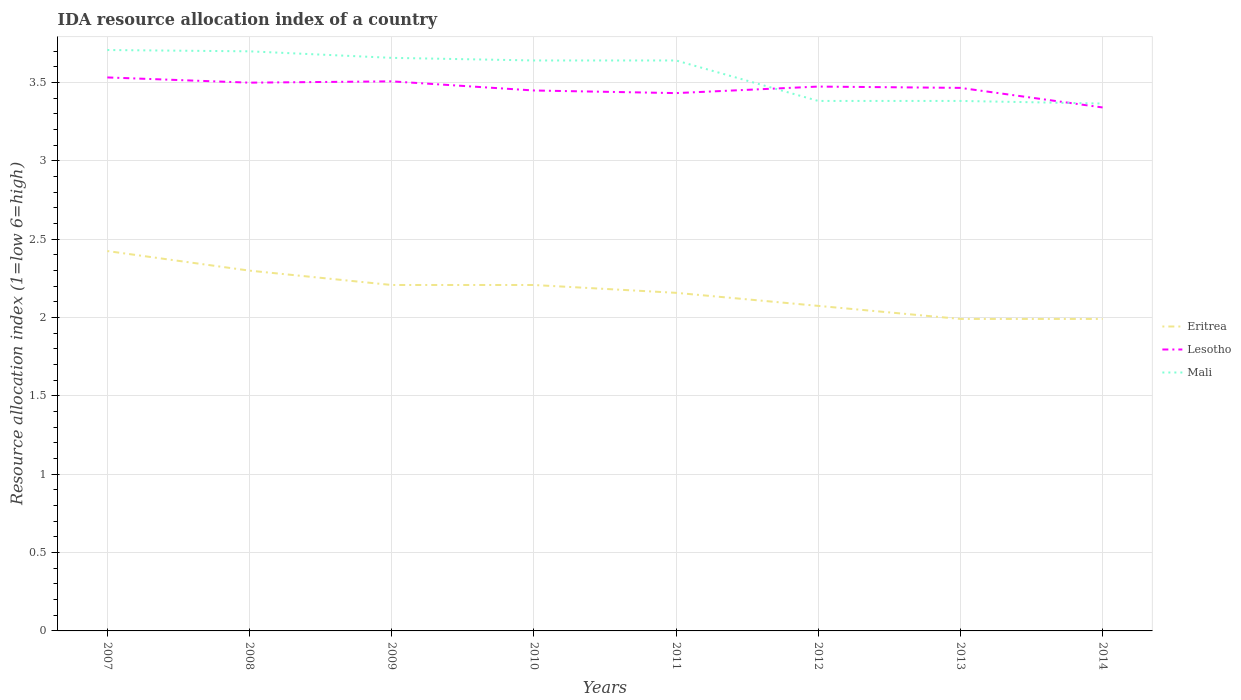How many different coloured lines are there?
Keep it short and to the point. 3. Across all years, what is the maximum IDA resource allocation index in Eritrea?
Your answer should be compact. 1.99. In which year was the IDA resource allocation index in Lesotho maximum?
Give a very brief answer. 2014. What is the total IDA resource allocation index in Lesotho in the graph?
Make the answer very short. 0.03. What is the difference between the highest and the second highest IDA resource allocation index in Mali?
Ensure brevity in your answer.  0.34. How many lines are there?
Provide a short and direct response. 3. Does the graph contain any zero values?
Provide a succinct answer. No. Does the graph contain grids?
Keep it short and to the point. Yes. Where does the legend appear in the graph?
Your answer should be very brief. Center right. What is the title of the graph?
Provide a succinct answer. IDA resource allocation index of a country. What is the label or title of the Y-axis?
Provide a short and direct response. Resource allocation index (1=low 6=high). What is the Resource allocation index (1=low 6=high) in Eritrea in 2007?
Provide a short and direct response. 2.42. What is the Resource allocation index (1=low 6=high) of Lesotho in 2007?
Ensure brevity in your answer.  3.53. What is the Resource allocation index (1=low 6=high) in Mali in 2007?
Offer a very short reply. 3.71. What is the Resource allocation index (1=low 6=high) in Eritrea in 2008?
Offer a very short reply. 2.3. What is the Resource allocation index (1=low 6=high) of Eritrea in 2009?
Your response must be concise. 2.21. What is the Resource allocation index (1=low 6=high) in Lesotho in 2009?
Your answer should be very brief. 3.51. What is the Resource allocation index (1=low 6=high) of Mali in 2009?
Give a very brief answer. 3.66. What is the Resource allocation index (1=low 6=high) of Eritrea in 2010?
Offer a very short reply. 2.21. What is the Resource allocation index (1=low 6=high) of Lesotho in 2010?
Provide a succinct answer. 3.45. What is the Resource allocation index (1=low 6=high) in Mali in 2010?
Your response must be concise. 3.64. What is the Resource allocation index (1=low 6=high) in Eritrea in 2011?
Your response must be concise. 2.16. What is the Resource allocation index (1=low 6=high) of Lesotho in 2011?
Provide a short and direct response. 3.43. What is the Resource allocation index (1=low 6=high) of Mali in 2011?
Give a very brief answer. 3.64. What is the Resource allocation index (1=low 6=high) of Eritrea in 2012?
Your answer should be very brief. 2.08. What is the Resource allocation index (1=low 6=high) of Lesotho in 2012?
Provide a short and direct response. 3.48. What is the Resource allocation index (1=low 6=high) of Mali in 2012?
Offer a very short reply. 3.38. What is the Resource allocation index (1=low 6=high) in Eritrea in 2013?
Keep it short and to the point. 1.99. What is the Resource allocation index (1=low 6=high) of Lesotho in 2013?
Keep it short and to the point. 3.47. What is the Resource allocation index (1=low 6=high) in Mali in 2013?
Offer a terse response. 3.38. What is the Resource allocation index (1=low 6=high) of Eritrea in 2014?
Give a very brief answer. 1.99. What is the Resource allocation index (1=low 6=high) in Lesotho in 2014?
Provide a succinct answer. 3.34. What is the Resource allocation index (1=low 6=high) in Mali in 2014?
Offer a very short reply. 3.37. Across all years, what is the maximum Resource allocation index (1=low 6=high) in Eritrea?
Give a very brief answer. 2.42. Across all years, what is the maximum Resource allocation index (1=low 6=high) in Lesotho?
Ensure brevity in your answer.  3.53. Across all years, what is the maximum Resource allocation index (1=low 6=high) of Mali?
Your response must be concise. 3.71. Across all years, what is the minimum Resource allocation index (1=low 6=high) of Eritrea?
Your response must be concise. 1.99. Across all years, what is the minimum Resource allocation index (1=low 6=high) in Lesotho?
Ensure brevity in your answer.  3.34. Across all years, what is the minimum Resource allocation index (1=low 6=high) of Mali?
Offer a very short reply. 3.37. What is the total Resource allocation index (1=low 6=high) of Eritrea in the graph?
Your answer should be compact. 17.36. What is the total Resource allocation index (1=low 6=high) of Lesotho in the graph?
Provide a succinct answer. 27.71. What is the total Resource allocation index (1=low 6=high) in Mali in the graph?
Make the answer very short. 28.48. What is the difference between the Resource allocation index (1=low 6=high) in Mali in 2007 and that in 2008?
Keep it short and to the point. 0.01. What is the difference between the Resource allocation index (1=low 6=high) in Eritrea in 2007 and that in 2009?
Offer a very short reply. 0.22. What is the difference between the Resource allocation index (1=low 6=high) of Lesotho in 2007 and that in 2009?
Your answer should be compact. 0.03. What is the difference between the Resource allocation index (1=low 6=high) in Eritrea in 2007 and that in 2010?
Make the answer very short. 0.22. What is the difference between the Resource allocation index (1=low 6=high) in Lesotho in 2007 and that in 2010?
Offer a very short reply. 0.08. What is the difference between the Resource allocation index (1=low 6=high) in Mali in 2007 and that in 2010?
Provide a succinct answer. 0.07. What is the difference between the Resource allocation index (1=low 6=high) in Eritrea in 2007 and that in 2011?
Give a very brief answer. 0.27. What is the difference between the Resource allocation index (1=low 6=high) of Lesotho in 2007 and that in 2011?
Offer a very short reply. 0.1. What is the difference between the Resource allocation index (1=low 6=high) of Mali in 2007 and that in 2011?
Give a very brief answer. 0.07. What is the difference between the Resource allocation index (1=low 6=high) in Lesotho in 2007 and that in 2012?
Your response must be concise. 0.06. What is the difference between the Resource allocation index (1=low 6=high) of Mali in 2007 and that in 2012?
Give a very brief answer. 0.33. What is the difference between the Resource allocation index (1=low 6=high) in Eritrea in 2007 and that in 2013?
Offer a very short reply. 0.43. What is the difference between the Resource allocation index (1=low 6=high) in Lesotho in 2007 and that in 2013?
Offer a terse response. 0.07. What is the difference between the Resource allocation index (1=low 6=high) in Mali in 2007 and that in 2013?
Provide a short and direct response. 0.33. What is the difference between the Resource allocation index (1=low 6=high) in Eritrea in 2007 and that in 2014?
Keep it short and to the point. 0.43. What is the difference between the Resource allocation index (1=low 6=high) in Lesotho in 2007 and that in 2014?
Provide a short and direct response. 0.19. What is the difference between the Resource allocation index (1=low 6=high) of Mali in 2007 and that in 2014?
Provide a short and direct response. 0.34. What is the difference between the Resource allocation index (1=low 6=high) in Eritrea in 2008 and that in 2009?
Your response must be concise. 0.09. What is the difference between the Resource allocation index (1=low 6=high) of Lesotho in 2008 and that in 2009?
Give a very brief answer. -0.01. What is the difference between the Resource allocation index (1=low 6=high) of Mali in 2008 and that in 2009?
Make the answer very short. 0.04. What is the difference between the Resource allocation index (1=low 6=high) of Eritrea in 2008 and that in 2010?
Your answer should be very brief. 0.09. What is the difference between the Resource allocation index (1=low 6=high) of Lesotho in 2008 and that in 2010?
Provide a succinct answer. 0.05. What is the difference between the Resource allocation index (1=low 6=high) in Mali in 2008 and that in 2010?
Ensure brevity in your answer.  0.06. What is the difference between the Resource allocation index (1=low 6=high) in Eritrea in 2008 and that in 2011?
Keep it short and to the point. 0.14. What is the difference between the Resource allocation index (1=low 6=high) in Lesotho in 2008 and that in 2011?
Provide a short and direct response. 0.07. What is the difference between the Resource allocation index (1=low 6=high) of Mali in 2008 and that in 2011?
Keep it short and to the point. 0.06. What is the difference between the Resource allocation index (1=low 6=high) in Eritrea in 2008 and that in 2012?
Offer a terse response. 0.23. What is the difference between the Resource allocation index (1=low 6=high) in Lesotho in 2008 and that in 2012?
Give a very brief answer. 0.03. What is the difference between the Resource allocation index (1=low 6=high) in Mali in 2008 and that in 2012?
Offer a terse response. 0.32. What is the difference between the Resource allocation index (1=low 6=high) in Eritrea in 2008 and that in 2013?
Provide a succinct answer. 0.31. What is the difference between the Resource allocation index (1=low 6=high) of Mali in 2008 and that in 2013?
Offer a very short reply. 0.32. What is the difference between the Resource allocation index (1=low 6=high) of Eritrea in 2008 and that in 2014?
Offer a very short reply. 0.31. What is the difference between the Resource allocation index (1=low 6=high) of Lesotho in 2008 and that in 2014?
Your answer should be very brief. 0.16. What is the difference between the Resource allocation index (1=low 6=high) of Mali in 2008 and that in 2014?
Make the answer very short. 0.33. What is the difference between the Resource allocation index (1=low 6=high) in Lesotho in 2009 and that in 2010?
Make the answer very short. 0.06. What is the difference between the Resource allocation index (1=low 6=high) in Mali in 2009 and that in 2010?
Make the answer very short. 0.02. What is the difference between the Resource allocation index (1=low 6=high) in Eritrea in 2009 and that in 2011?
Give a very brief answer. 0.05. What is the difference between the Resource allocation index (1=low 6=high) of Lesotho in 2009 and that in 2011?
Offer a terse response. 0.07. What is the difference between the Resource allocation index (1=low 6=high) of Mali in 2009 and that in 2011?
Ensure brevity in your answer.  0.02. What is the difference between the Resource allocation index (1=low 6=high) in Eritrea in 2009 and that in 2012?
Give a very brief answer. 0.13. What is the difference between the Resource allocation index (1=low 6=high) in Lesotho in 2009 and that in 2012?
Provide a succinct answer. 0.03. What is the difference between the Resource allocation index (1=low 6=high) of Mali in 2009 and that in 2012?
Provide a short and direct response. 0.28. What is the difference between the Resource allocation index (1=low 6=high) of Eritrea in 2009 and that in 2013?
Your answer should be compact. 0.22. What is the difference between the Resource allocation index (1=low 6=high) of Lesotho in 2009 and that in 2013?
Offer a terse response. 0.04. What is the difference between the Resource allocation index (1=low 6=high) in Mali in 2009 and that in 2013?
Your response must be concise. 0.28. What is the difference between the Resource allocation index (1=low 6=high) of Eritrea in 2009 and that in 2014?
Your answer should be very brief. 0.22. What is the difference between the Resource allocation index (1=low 6=high) in Lesotho in 2009 and that in 2014?
Your answer should be compact. 0.17. What is the difference between the Resource allocation index (1=low 6=high) in Mali in 2009 and that in 2014?
Make the answer very short. 0.29. What is the difference between the Resource allocation index (1=low 6=high) in Lesotho in 2010 and that in 2011?
Your answer should be very brief. 0.02. What is the difference between the Resource allocation index (1=low 6=high) in Eritrea in 2010 and that in 2012?
Keep it short and to the point. 0.13. What is the difference between the Resource allocation index (1=low 6=high) of Lesotho in 2010 and that in 2012?
Offer a very short reply. -0.03. What is the difference between the Resource allocation index (1=low 6=high) of Mali in 2010 and that in 2012?
Your response must be concise. 0.26. What is the difference between the Resource allocation index (1=low 6=high) of Eritrea in 2010 and that in 2013?
Provide a succinct answer. 0.22. What is the difference between the Resource allocation index (1=low 6=high) in Lesotho in 2010 and that in 2013?
Offer a terse response. -0.02. What is the difference between the Resource allocation index (1=low 6=high) of Mali in 2010 and that in 2013?
Provide a short and direct response. 0.26. What is the difference between the Resource allocation index (1=low 6=high) in Eritrea in 2010 and that in 2014?
Your answer should be compact. 0.22. What is the difference between the Resource allocation index (1=low 6=high) in Lesotho in 2010 and that in 2014?
Ensure brevity in your answer.  0.11. What is the difference between the Resource allocation index (1=low 6=high) in Mali in 2010 and that in 2014?
Offer a very short reply. 0.28. What is the difference between the Resource allocation index (1=low 6=high) in Eritrea in 2011 and that in 2012?
Offer a very short reply. 0.08. What is the difference between the Resource allocation index (1=low 6=high) in Lesotho in 2011 and that in 2012?
Offer a terse response. -0.04. What is the difference between the Resource allocation index (1=low 6=high) in Mali in 2011 and that in 2012?
Offer a terse response. 0.26. What is the difference between the Resource allocation index (1=low 6=high) of Lesotho in 2011 and that in 2013?
Provide a succinct answer. -0.03. What is the difference between the Resource allocation index (1=low 6=high) of Mali in 2011 and that in 2013?
Your answer should be compact. 0.26. What is the difference between the Resource allocation index (1=low 6=high) in Eritrea in 2011 and that in 2014?
Offer a terse response. 0.17. What is the difference between the Resource allocation index (1=low 6=high) of Lesotho in 2011 and that in 2014?
Provide a short and direct response. 0.09. What is the difference between the Resource allocation index (1=low 6=high) of Mali in 2011 and that in 2014?
Your response must be concise. 0.28. What is the difference between the Resource allocation index (1=low 6=high) of Eritrea in 2012 and that in 2013?
Your answer should be very brief. 0.08. What is the difference between the Resource allocation index (1=low 6=high) of Lesotho in 2012 and that in 2013?
Provide a succinct answer. 0.01. What is the difference between the Resource allocation index (1=low 6=high) of Eritrea in 2012 and that in 2014?
Make the answer very short. 0.08. What is the difference between the Resource allocation index (1=low 6=high) in Lesotho in 2012 and that in 2014?
Your answer should be compact. 0.13. What is the difference between the Resource allocation index (1=low 6=high) in Mali in 2012 and that in 2014?
Provide a succinct answer. 0.02. What is the difference between the Resource allocation index (1=low 6=high) of Lesotho in 2013 and that in 2014?
Provide a short and direct response. 0.12. What is the difference between the Resource allocation index (1=low 6=high) of Mali in 2013 and that in 2014?
Keep it short and to the point. 0.02. What is the difference between the Resource allocation index (1=low 6=high) in Eritrea in 2007 and the Resource allocation index (1=low 6=high) in Lesotho in 2008?
Keep it short and to the point. -1.07. What is the difference between the Resource allocation index (1=low 6=high) in Eritrea in 2007 and the Resource allocation index (1=low 6=high) in Mali in 2008?
Provide a succinct answer. -1.27. What is the difference between the Resource allocation index (1=low 6=high) in Lesotho in 2007 and the Resource allocation index (1=low 6=high) in Mali in 2008?
Provide a short and direct response. -0.17. What is the difference between the Resource allocation index (1=low 6=high) in Eritrea in 2007 and the Resource allocation index (1=low 6=high) in Lesotho in 2009?
Provide a short and direct response. -1.08. What is the difference between the Resource allocation index (1=low 6=high) in Eritrea in 2007 and the Resource allocation index (1=low 6=high) in Mali in 2009?
Give a very brief answer. -1.23. What is the difference between the Resource allocation index (1=low 6=high) in Lesotho in 2007 and the Resource allocation index (1=low 6=high) in Mali in 2009?
Ensure brevity in your answer.  -0.12. What is the difference between the Resource allocation index (1=low 6=high) in Eritrea in 2007 and the Resource allocation index (1=low 6=high) in Lesotho in 2010?
Offer a terse response. -1.02. What is the difference between the Resource allocation index (1=low 6=high) in Eritrea in 2007 and the Resource allocation index (1=low 6=high) in Mali in 2010?
Your answer should be very brief. -1.22. What is the difference between the Resource allocation index (1=low 6=high) of Lesotho in 2007 and the Resource allocation index (1=low 6=high) of Mali in 2010?
Provide a succinct answer. -0.11. What is the difference between the Resource allocation index (1=low 6=high) of Eritrea in 2007 and the Resource allocation index (1=low 6=high) of Lesotho in 2011?
Your answer should be compact. -1.01. What is the difference between the Resource allocation index (1=low 6=high) in Eritrea in 2007 and the Resource allocation index (1=low 6=high) in Mali in 2011?
Provide a succinct answer. -1.22. What is the difference between the Resource allocation index (1=low 6=high) of Lesotho in 2007 and the Resource allocation index (1=low 6=high) of Mali in 2011?
Your answer should be very brief. -0.11. What is the difference between the Resource allocation index (1=low 6=high) in Eritrea in 2007 and the Resource allocation index (1=low 6=high) in Lesotho in 2012?
Your answer should be compact. -1.05. What is the difference between the Resource allocation index (1=low 6=high) of Eritrea in 2007 and the Resource allocation index (1=low 6=high) of Mali in 2012?
Give a very brief answer. -0.96. What is the difference between the Resource allocation index (1=low 6=high) of Eritrea in 2007 and the Resource allocation index (1=low 6=high) of Lesotho in 2013?
Offer a terse response. -1.04. What is the difference between the Resource allocation index (1=low 6=high) of Eritrea in 2007 and the Resource allocation index (1=low 6=high) of Mali in 2013?
Make the answer very short. -0.96. What is the difference between the Resource allocation index (1=low 6=high) of Lesotho in 2007 and the Resource allocation index (1=low 6=high) of Mali in 2013?
Make the answer very short. 0.15. What is the difference between the Resource allocation index (1=low 6=high) of Eritrea in 2007 and the Resource allocation index (1=low 6=high) of Lesotho in 2014?
Provide a short and direct response. -0.92. What is the difference between the Resource allocation index (1=low 6=high) in Eritrea in 2007 and the Resource allocation index (1=low 6=high) in Mali in 2014?
Offer a terse response. -0.94. What is the difference between the Resource allocation index (1=low 6=high) in Eritrea in 2008 and the Resource allocation index (1=low 6=high) in Lesotho in 2009?
Keep it short and to the point. -1.21. What is the difference between the Resource allocation index (1=low 6=high) of Eritrea in 2008 and the Resource allocation index (1=low 6=high) of Mali in 2009?
Offer a very short reply. -1.36. What is the difference between the Resource allocation index (1=low 6=high) in Lesotho in 2008 and the Resource allocation index (1=low 6=high) in Mali in 2009?
Provide a short and direct response. -0.16. What is the difference between the Resource allocation index (1=low 6=high) of Eritrea in 2008 and the Resource allocation index (1=low 6=high) of Lesotho in 2010?
Keep it short and to the point. -1.15. What is the difference between the Resource allocation index (1=low 6=high) in Eritrea in 2008 and the Resource allocation index (1=low 6=high) in Mali in 2010?
Your answer should be compact. -1.34. What is the difference between the Resource allocation index (1=low 6=high) of Lesotho in 2008 and the Resource allocation index (1=low 6=high) of Mali in 2010?
Keep it short and to the point. -0.14. What is the difference between the Resource allocation index (1=low 6=high) in Eritrea in 2008 and the Resource allocation index (1=low 6=high) in Lesotho in 2011?
Keep it short and to the point. -1.13. What is the difference between the Resource allocation index (1=low 6=high) in Eritrea in 2008 and the Resource allocation index (1=low 6=high) in Mali in 2011?
Keep it short and to the point. -1.34. What is the difference between the Resource allocation index (1=low 6=high) in Lesotho in 2008 and the Resource allocation index (1=low 6=high) in Mali in 2011?
Your response must be concise. -0.14. What is the difference between the Resource allocation index (1=low 6=high) in Eritrea in 2008 and the Resource allocation index (1=low 6=high) in Lesotho in 2012?
Offer a very short reply. -1.18. What is the difference between the Resource allocation index (1=low 6=high) of Eritrea in 2008 and the Resource allocation index (1=low 6=high) of Mali in 2012?
Make the answer very short. -1.08. What is the difference between the Resource allocation index (1=low 6=high) of Lesotho in 2008 and the Resource allocation index (1=low 6=high) of Mali in 2012?
Keep it short and to the point. 0.12. What is the difference between the Resource allocation index (1=low 6=high) of Eritrea in 2008 and the Resource allocation index (1=low 6=high) of Lesotho in 2013?
Keep it short and to the point. -1.17. What is the difference between the Resource allocation index (1=low 6=high) in Eritrea in 2008 and the Resource allocation index (1=low 6=high) in Mali in 2013?
Ensure brevity in your answer.  -1.08. What is the difference between the Resource allocation index (1=low 6=high) of Lesotho in 2008 and the Resource allocation index (1=low 6=high) of Mali in 2013?
Your response must be concise. 0.12. What is the difference between the Resource allocation index (1=low 6=high) in Eritrea in 2008 and the Resource allocation index (1=low 6=high) in Lesotho in 2014?
Offer a terse response. -1.04. What is the difference between the Resource allocation index (1=low 6=high) in Eritrea in 2008 and the Resource allocation index (1=low 6=high) in Mali in 2014?
Provide a short and direct response. -1.07. What is the difference between the Resource allocation index (1=low 6=high) of Lesotho in 2008 and the Resource allocation index (1=low 6=high) of Mali in 2014?
Your answer should be very brief. 0.13. What is the difference between the Resource allocation index (1=low 6=high) in Eritrea in 2009 and the Resource allocation index (1=low 6=high) in Lesotho in 2010?
Keep it short and to the point. -1.24. What is the difference between the Resource allocation index (1=low 6=high) of Eritrea in 2009 and the Resource allocation index (1=low 6=high) of Mali in 2010?
Offer a very short reply. -1.43. What is the difference between the Resource allocation index (1=low 6=high) of Lesotho in 2009 and the Resource allocation index (1=low 6=high) of Mali in 2010?
Make the answer very short. -0.13. What is the difference between the Resource allocation index (1=low 6=high) in Eritrea in 2009 and the Resource allocation index (1=low 6=high) in Lesotho in 2011?
Ensure brevity in your answer.  -1.23. What is the difference between the Resource allocation index (1=low 6=high) in Eritrea in 2009 and the Resource allocation index (1=low 6=high) in Mali in 2011?
Your response must be concise. -1.43. What is the difference between the Resource allocation index (1=low 6=high) in Lesotho in 2009 and the Resource allocation index (1=low 6=high) in Mali in 2011?
Ensure brevity in your answer.  -0.13. What is the difference between the Resource allocation index (1=low 6=high) of Eritrea in 2009 and the Resource allocation index (1=low 6=high) of Lesotho in 2012?
Your response must be concise. -1.27. What is the difference between the Resource allocation index (1=low 6=high) in Eritrea in 2009 and the Resource allocation index (1=low 6=high) in Mali in 2012?
Make the answer very short. -1.18. What is the difference between the Resource allocation index (1=low 6=high) in Lesotho in 2009 and the Resource allocation index (1=low 6=high) in Mali in 2012?
Offer a very short reply. 0.12. What is the difference between the Resource allocation index (1=low 6=high) in Eritrea in 2009 and the Resource allocation index (1=low 6=high) in Lesotho in 2013?
Offer a terse response. -1.26. What is the difference between the Resource allocation index (1=low 6=high) of Eritrea in 2009 and the Resource allocation index (1=low 6=high) of Mali in 2013?
Ensure brevity in your answer.  -1.18. What is the difference between the Resource allocation index (1=low 6=high) of Lesotho in 2009 and the Resource allocation index (1=low 6=high) of Mali in 2013?
Ensure brevity in your answer.  0.12. What is the difference between the Resource allocation index (1=low 6=high) in Eritrea in 2009 and the Resource allocation index (1=low 6=high) in Lesotho in 2014?
Ensure brevity in your answer.  -1.13. What is the difference between the Resource allocation index (1=low 6=high) in Eritrea in 2009 and the Resource allocation index (1=low 6=high) in Mali in 2014?
Keep it short and to the point. -1.16. What is the difference between the Resource allocation index (1=low 6=high) of Lesotho in 2009 and the Resource allocation index (1=low 6=high) of Mali in 2014?
Your answer should be very brief. 0.14. What is the difference between the Resource allocation index (1=low 6=high) of Eritrea in 2010 and the Resource allocation index (1=low 6=high) of Lesotho in 2011?
Give a very brief answer. -1.23. What is the difference between the Resource allocation index (1=low 6=high) of Eritrea in 2010 and the Resource allocation index (1=low 6=high) of Mali in 2011?
Ensure brevity in your answer.  -1.43. What is the difference between the Resource allocation index (1=low 6=high) in Lesotho in 2010 and the Resource allocation index (1=low 6=high) in Mali in 2011?
Keep it short and to the point. -0.19. What is the difference between the Resource allocation index (1=low 6=high) in Eritrea in 2010 and the Resource allocation index (1=low 6=high) in Lesotho in 2012?
Your response must be concise. -1.27. What is the difference between the Resource allocation index (1=low 6=high) of Eritrea in 2010 and the Resource allocation index (1=low 6=high) of Mali in 2012?
Provide a short and direct response. -1.18. What is the difference between the Resource allocation index (1=low 6=high) in Lesotho in 2010 and the Resource allocation index (1=low 6=high) in Mali in 2012?
Your answer should be very brief. 0.07. What is the difference between the Resource allocation index (1=low 6=high) of Eritrea in 2010 and the Resource allocation index (1=low 6=high) of Lesotho in 2013?
Keep it short and to the point. -1.26. What is the difference between the Resource allocation index (1=low 6=high) in Eritrea in 2010 and the Resource allocation index (1=low 6=high) in Mali in 2013?
Your answer should be very brief. -1.18. What is the difference between the Resource allocation index (1=low 6=high) in Lesotho in 2010 and the Resource allocation index (1=low 6=high) in Mali in 2013?
Make the answer very short. 0.07. What is the difference between the Resource allocation index (1=low 6=high) of Eritrea in 2010 and the Resource allocation index (1=low 6=high) of Lesotho in 2014?
Give a very brief answer. -1.13. What is the difference between the Resource allocation index (1=low 6=high) of Eritrea in 2010 and the Resource allocation index (1=low 6=high) of Mali in 2014?
Offer a very short reply. -1.16. What is the difference between the Resource allocation index (1=low 6=high) in Lesotho in 2010 and the Resource allocation index (1=low 6=high) in Mali in 2014?
Ensure brevity in your answer.  0.08. What is the difference between the Resource allocation index (1=low 6=high) in Eritrea in 2011 and the Resource allocation index (1=low 6=high) in Lesotho in 2012?
Offer a terse response. -1.32. What is the difference between the Resource allocation index (1=low 6=high) of Eritrea in 2011 and the Resource allocation index (1=low 6=high) of Mali in 2012?
Offer a terse response. -1.23. What is the difference between the Resource allocation index (1=low 6=high) in Eritrea in 2011 and the Resource allocation index (1=low 6=high) in Lesotho in 2013?
Offer a very short reply. -1.31. What is the difference between the Resource allocation index (1=low 6=high) of Eritrea in 2011 and the Resource allocation index (1=low 6=high) of Mali in 2013?
Give a very brief answer. -1.23. What is the difference between the Resource allocation index (1=low 6=high) in Lesotho in 2011 and the Resource allocation index (1=low 6=high) in Mali in 2013?
Your answer should be very brief. 0.05. What is the difference between the Resource allocation index (1=low 6=high) of Eritrea in 2011 and the Resource allocation index (1=low 6=high) of Lesotho in 2014?
Ensure brevity in your answer.  -1.18. What is the difference between the Resource allocation index (1=low 6=high) in Eritrea in 2011 and the Resource allocation index (1=low 6=high) in Mali in 2014?
Offer a very short reply. -1.21. What is the difference between the Resource allocation index (1=low 6=high) of Lesotho in 2011 and the Resource allocation index (1=low 6=high) of Mali in 2014?
Your answer should be compact. 0.07. What is the difference between the Resource allocation index (1=low 6=high) of Eritrea in 2012 and the Resource allocation index (1=low 6=high) of Lesotho in 2013?
Your answer should be compact. -1.39. What is the difference between the Resource allocation index (1=low 6=high) in Eritrea in 2012 and the Resource allocation index (1=low 6=high) in Mali in 2013?
Your response must be concise. -1.31. What is the difference between the Resource allocation index (1=low 6=high) of Lesotho in 2012 and the Resource allocation index (1=low 6=high) of Mali in 2013?
Provide a short and direct response. 0.09. What is the difference between the Resource allocation index (1=low 6=high) of Eritrea in 2012 and the Resource allocation index (1=low 6=high) of Lesotho in 2014?
Your answer should be very brief. -1.27. What is the difference between the Resource allocation index (1=low 6=high) in Eritrea in 2012 and the Resource allocation index (1=low 6=high) in Mali in 2014?
Provide a short and direct response. -1.29. What is the difference between the Resource allocation index (1=low 6=high) in Lesotho in 2012 and the Resource allocation index (1=low 6=high) in Mali in 2014?
Provide a short and direct response. 0.11. What is the difference between the Resource allocation index (1=low 6=high) in Eritrea in 2013 and the Resource allocation index (1=low 6=high) in Lesotho in 2014?
Make the answer very short. -1.35. What is the difference between the Resource allocation index (1=low 6=high) in Eritrea in 2013 and the Resource allocation index (1=low 6=high) in Mali in 2014?
Offer a terse response. -1.38. What is the difference between the Resource allocation index (1=low 6=high) in Lesotho in 2013 and the Resource allocation index (1=low 6=high) in Mali in 2014?
Your response must be concise. 0.1. What is the average Resource allocation index (1=low 6=high) in Eritrea per year?
Ensure brevity in your answer.  2.17. What is the average Resource allocation index (1=low 6=high) in Lesotho per year?
Offer a very short reply. 3.46. What is the average Resource allocation index (1=low 6=high) in Mali per year?
Offer a terse response. 3.56. In the year 2007, what is the difference between the Resource allocation index (1=low 6=high) of Eritrea and Resource allocation index (1=low 6=high) of Lesotho?
Provide a succinct answer. -1.11. In the year 2007, what is the difference between the Resource allocation index (1=low 6=high) of Eritrea and Resource allocation index (1=low 6=high) of Mali?
Your response must be concise. -1.28. In the year 2007, what is the difference between the Resource allocation index (1=low 6=high) in Lesotho and Resource allocation index (1=low 6=high) in Mali?
Provide a succinct answer. -0.17. In the year 2008, what is the difference between the Resource allocation index (1=low 6=high) in Eritrea and Resource allocation index (1=low 6=high) in Mali?
Give a very brief answer. -1.4. In the year 2008, what is the difference between the Resource allocation index (1=low 6=high) in Lesotho and Resource allocation index (1=low 6=high) in Mali?
Your response must be concise. -0.2. In the year 2009, what is the difference between the Resource allocation index (1=low 6=high) in Eritrea and Resource allocation index (1=low 6=high) in Lesotho?
Give a very brief answer. -1.3. In the year 2009, what is the difference between the Resource allocation index (1=low 6=high) of Eritrea and Resource allocation index (1=low 6=high) of Mali?
Provide a short and direct response. -1.45. In the year 2009, what is the difference between the Resource allocation index (1=low 6=high) in Lesotho and Resource allocation index (1=low 6=high) in Mali?
Offer a very short reply. -0.15. In the year 2010, what is the difference between the Resource allocation index (1=low 6=high) in Eritrea and Resource allocation index (1=low 6=high) in Lesotho?
Keep it short and to the point. -1.24. In the year 2010, what is the difference between the Resource allocation index (1=low 6=high) in Eritrea and Resource allocation index (1=low 6=high) in Mali?
Your answer should be compact. -1.43. In the year 2010, what is the difference between the Resource allocation index (1=low 6=high) of Lesotho and Resource allocation index (1=low 6=high) of Mali?
Provide a short and direct response. -0.19. In the year 2011, what is the difference between the Resource allocation index (1=low 6=high) of Eritrea and Resource allocation index (1=low 6=high) of Lesotho?
Provide a succinct answer. -1.27. In the year 2011, what is the difference between the Resource allocation index (1=low 6=high) of Eritrea and Resource allocation index (1=low 6=high) of Mali?
Offer a very short reply. -1.48. In the year 2011, what is the difference between the Resource allocation index (1=low 6=high) in Lesotho and Resource allocation index (1=low 6=high) in Mali?
Offer a terse response. -0.21. In the year 2012, what is the difference between the Resource allocation index (1=low 6=high) in Eritrea and Resource allocation index (1=low 6=high) in Lesotho?
Make the answer very short. -1.4. In the year 2012, what is the difference between the Resource allocation index (1=low 6=high) in Eritrea and Resource allocation index (1=low 6=high) in Mali?
Ensure brevity in your answer.  -1.31. In the year 2012, what is the difference between the Resource allocation index (1=low 6=high) of Lesotho and Resource allocation index (1=low 6=high) of Mali?
Offer a very short reply. 0.09. In the year 2013, what is the difference between the Resource allocation index (1=low 6=high) in Eritrea and Resource allocation index (1=low 6=high) in Lesotho?
Your response must be concise. -1.48. In the year 2013, what is the difference between the Resource allocation index (1=low 6=high) in Eritrea and Resource allocation index (1=low 6=high) in Mali?
Give a very brief answer. -1.39. In the year 2013, what is the difference between the Resource allocation index (1=low 6=high) of Lesotho and Resource allocation index (1=low 6=high) of Mali?
Make the answer very short. 0.08. In the year 2014, what is the difference between the Resource allocation index (1=low 6=high) of Eritrea and Resource allocation index (1=low 6=high) of Lesotho?
Offer a very short reply. -1.35. In the year 2014, what is the difference between the Resource allocation index (1=low 6=high) of Eritrea and Resource allocation index (1=low 6=high) of Mali?
Your answer should be very brief. -1.38. In the year 2014, what is the difference between the Resource allocation index (1=low 6=high) in Lesotho and Resource allocation index (1=low 6=high) in Mali?
Ensure brevity in your answer.  -0.03. What is the ratio of the Resource allocation index (1=low 6=high) in Eritrea in 2007 to that in 2008?
Ensure brevity in your answer.  1.05. What is the ratio of the Resource allocation index (1=low 6=high) of Lesotho in 2007 to that in 2008?
Your answer should be compact. 1.01. What is the ratio of the Resource allocation index (1=low 6=high) in Eritrea in 2007 to that in 2009?
Make the answer very short. 1.1. What is the ratio of the Resource allocation index (1=low 6=high) of Lesotho in 2007 to that in 2009?
Give a very brief answer. 1.01. What is the ratio of the Resource allocation index (1=low 6=high) in Mali in 2007 to that in 2009?
Provide a short and direct response. 1.01. What is the ratio of the Resource allocation index (1=low 6=high) in Eritrea in 2007 to that in 2010?
Your answer should be very brief. 1.1. What is the ratio of the Resource allocation index (1=low 6=high) in Lesotho in 2007 to that in 2010?
Provide a succinct answer. 1.02. What is the ratio of the Resource allocation index (1=low 6=high) in Mali in 2007 to that in 2010?
Keep it short and to the point. 1.02. What is the ratio of the Resource allocation index (1=low 6=high) of Eritrea in 2007 to that in 2011?
Make the answer very short. 1.12. What is the ratio of the Resource allocation index (1=low 6=high) in Lesotho in 2007 to that in 2011?
Your answer should be very brief. 1.03. What is the ratio of the Resource allocation index (1=low 6=high) in Mali in 2007 to that in 2011?
Provide a succinct answer. 1.02. What is the ratio of the Resource allocation index (1=low 6=high) in Eritrea in 2007 to that in 2012?
Your answer should be compact. 1.17. What is the ratio of the Resource allocation index (1=low 6=high) of Lesotho in 2007 to that in 2012?
Ensure brevity in your answer.  1.02. What is the ratio of the Resource allocation index (1=low 6=high) of Mali in 2007 to that in 2012?
Ensure brevity in your answer.  1.1. What is the ratio of the Resource allocation index (1=low 6=high) of Eritrea in 2007 to that in 2013?
Give a very brief answer. 1.22. What is the ratio of the Resource allocation index (1=low 6=high) in Lesotho in 2007 to that in 2013?
Offer a terse response. 1.02. What is the ratio of the Resource allocation index (1=low 6=high) of Mali in 2007 to that in 2013?
Offer a very short reply. 1.1. What is the ratio of the Resource allocation index (1=low 6=high) in Eritrea in 2007 to that in 2014?
Your response must be concise. 1.22. What is the ratio of the Resource allocation index (1=low 6=high) in Lesotho in 2007 to that in 2014?
Make the answer very short. 1.06. What is the ratio of the Resource allocation index (1=low 6=high) in Mali in 2007 to that in 2014?
Ensure brevity in your answer.  1.1. What is the ratio of the Resource allocation index (1=low 6=high) in Eritrea in 2008 to that in 2009?
Provide a succinct answer. 1.04. What is the ratio of the Resource allocation index (1=low 6=high) of Mali in 2008 to that in 2009?
Provide a succinct answer. 1.01. What is the ratio of the Resource allocation index (1=low 6=high) in Eritrea in 2008 to that in 2010?
Your answer should be very brief. 1.04. What is the ratio of the Resource allocation index (1=low 6=high) of Lesotho in 2008 to that in 2010?
Provide a short and direct response. 1.01. What is the ratio of the Resource allocation index (1=low 6=high) in Mali in 2008 to that in 2010?
Your response must be concise. 1.02. What is the ratio of the Resource allocation index (1=low 6=high) of Eritrea in 2008 to that in 2011?
Provide a short and direct response. 1.07. What is the ratio of the Resource allocation index (1=low 6=high) in Lesotho in 2008 to that in 2011?
Keep it short and to the point. 1.02. What is the ratio of the Resource allocation index (1=low 6=high) of Eritrea in 2008 to that in 2012?
Your response must be concise. 1.11. What is the ratio of the Resource allocation index (1=low 6=high) in Lesotho in 2008 to that in 2012?
Offer a very short reply. 1.01. What is the ratio of the Resource allocation index (1=low 6=high) in Mali in 2008 to that in 2012?
Provide a short and direct response. 1.09. What is the ratio of the Resource allocation index (1=low 6=high) in Eritrea in 2008 to that in 2013?
Offer a terse response. 1.15. What is the ratio of the Resource allocation index (1=low 6=high) of Lesotho in 2008 to that in 2013?
Provide a short and direct response. 1.01. What is the ratio of the Resource allocation index (1=low 6=high) of Mali in 2008 to that in 2013?
Offer a very short reply. 1.09. What is the ratio of the Resource allocation index (1=low 6=high) in Eritrea in 2008 to that in 2014?
Make the answer very short. 1.15. What is the ratio of the Resource allocation index (1=low 6=high) of Lesotho in 2008 to that in 2014?
Offer a terse response. 1.05. What is the ratio of the Resource allocation index (1=low 6=high) in Mali in 2008 to that in 2014?
Offer a very short reply. 1.1. What is the ratio of the Resource allocation index (1=low 6=high) in Lesotho in 2009 to that in 2010?
Make the answer very short. 1.02. What is the ratio of the Resource allocation index (1=low 6=high) in Eritrea in 2009 to that in 2011?
Give a very brief answer. 1.02. What is the ratio of the Resource allocation index (1=low 6=high) in Lesotho in 2009 to that in 2011?
Offer a very short reply. 1.02. What is the ratio of the Resource allocation index (1=low 6=high) of Eritrea in 2009 to that in 2012?
Your answer should be compact. 1.06. What is the ratio of the Resource allocation index (1=low 6=high) in Lesotho in 2009 to that in 2012?
Provide a succinct answer. 1.01. What is the ratio of the Resource allocation index (1=low 6=high) of Mali in 2009 to that in 2012?
Ensure brevity in your answer.  1.08. What is the ratio of the Resource allocation index (1=low 6=high) of Eritrea in 2009 to that in 2013?
Make the answer very short. 1.11. What is the ratio of the Resource allocation index (1=low 6=high) of Mali in 2009 to that in 2013?
Offer a terse response. 1.08. What is the ratio of the Resource allocation index (1=low 6=high) in Eritrea in 2009 to that in 2014?
Give a very brief answer. 1.11. What is the ratio of the Resource allocation index (1=low 6=high) of Lesotho in 2009 to that in 2014?
Offer a terse response. 1.05. What is the ratio of the Resource allocation index (1=low 6=high) in Mali in 2009 to that in 2014?
Your response must be concise. 1.09. What is the ratio of the Resource allocation index (1=low 6=high) of Eritrea in 2010 to that in 2011?
Keep it short and to the point. 1.02. What is the ratio of the Resource allocation index (1=low 6=high) in Lesotho in 2010 to that in 2011?
Your answer should be very brief. 1. What is the ratio of the Resource allocation index (1=low 6=high) in Eritrea in 2010 to that in 2012?
Provide a short and direct response. 1.06. What is the ratio of the Resource allocation index (1=low 6=high) of Lesotho in 2010 to that in 2012?
Make the answer very short. 0.99. What is the ratio of the Resource allocation index (1=low 6=high) of Mali in 2010 to that in 2012?
Your answer should be very brief. 1.08. What is the ratio of the Resource allocation index (1=low 6=high) in Eritrea in 2010 to that in 2013?
Offer a terse response. 1.11. What is the ratio of the Resource allocation index (1=low 6=high) in Mali in 2010 to that in 2013?
Make the answer very short. 1.08. What is the ratio of the Resource allocation index (1=low 6=high) in Eritrea in 2010 to that in 2014?
Ensure brevity in your answer.  1.11. What is the ratio of the Resource allocation index (1=low 6=high) in Lesotho in 2010 to that in 2014?
Make the answer very short. 1.03. What is the ratio of the Resource allocation index (1=low 6=high) in Mali in 2010 to that in 2014?
Offer a very short reply. 1.08. What is the ratio of the Resource allocation index (1=low 6=high) in Eritrea in 2011 to that in 2012?
Keep it short and to the point. 1.04. What is the ratio of the Resource allocation index (1=low 6=high) in Lesotho in 2011 to that in 2012?
Your answer should be very brief. 0.99. What is the ratio of the Resource allocation index (1=low 6=high) in Mali in 2011 to that in 2012?
Offer a very short reply. 1.08. What is the ratio of the Resource allocation index (1=low 6=high) in Eritrea in 2011 to that in 2013?
Your response must be concise. 1.08. What is the ratio of the Resource allocation index (1=low 6=high) of Lesotho in 2011 to that in 2013?
Ensure brevity in your answer.  0.99. What is the ratio of the Resource allocation index (1=low 6=high) in Mali in 2011 to that in 2013?
Make the answer very short. 1.08. What is the ratio of the Resource allocation index (1=low 6=high) in Eritrea in 2011 to that in 2014?
Your answer should be very brief. 1.08. What is the ratio of the Resource allocation index (1=low 6=high) in Lesotho in 2011 to that in 2014?
Give a very brief answer. 1.03. What is the ratio of the Resource allocation index (1=low 6=high) in Mali in 2011 to that in 2014?
Give a very brief answer. 1.08. What is the ratio of the Resource allocation index (1=low 6=high) of Eritrea in 2012 to that in 2013?
Your answer should be compact. 1.04. What is the ratio of the Resource allocation index (1=low 6=high) of Mali in 2012 to that in 2013?
Your answer should be compact. 1. What is the ratio of the Resource allocation index (1=low 6=high) in Eritrea in 2012 to that in 2014?
Keep it short and to the point. 1.04. What is the ratio of the Resource allocation index (1=low 6=high) of Lesotho in 2012 to that in 2014?
Keep it short and to the point. 1.04. What is the ratio of the Resource allocation index (1=low 6=high) of Mali in 2012 to that in 2014?
Keep it short and to the point. 1. What is the ratio of the Resource allocation index (1=low 6=high) in Eritrea in 2013 to that in 2014?
Make the answer very short. 1. What is the ratio of the Resource allocation index (1=low 6=high) in Lesotho in 2013 to that in 2014?
Offer a terse response. 1.04. What is the difference between the highest and the second highest Resource allocation index (1=low 6=high) of Eritrea?
Offer a very short reply. 0.12. What is the difference between the highest and the second highest Resource allocation index (1=low 6=high) in Lesotho?
Keep it short and to the point. 0.03. What is the difference between the highest and the second highest Resource allocation index (1=low 6=high) in Mali?
Your response must be concise. 0.01. What is the difference between the highest and the lowest Resource allocation index (1=low 6=high) in Eritrea?
Make the answer very short. 0.43. What is the difference between the highest and the lowest Resource allocation index (1=low 6=high) of Lesotho?
Offer a very short reply. 0.19. What is the difference between the highest and the lowest Resource allocation index (1=low 6=high) in Mali?
Offer a very short reply. 0.34. 